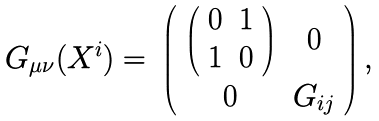Convert formula to latex. <formula><loc_0><loc_0><loc_500><loc_500>\begin{array} { c c } { { G _ { \mu \nu } ( X ^ { i } ) = } } & { { \left ( \begin{array} { c c } { { \left ( \begin{array} { c c } { 0 } & { 1 } \\ { 1 } & { 0 } \end{array} \right ) } } & { 0 } \\ { 0 } & { { G _ { i j } } } \end{array} \right ) , } } \end{array}</formula> 